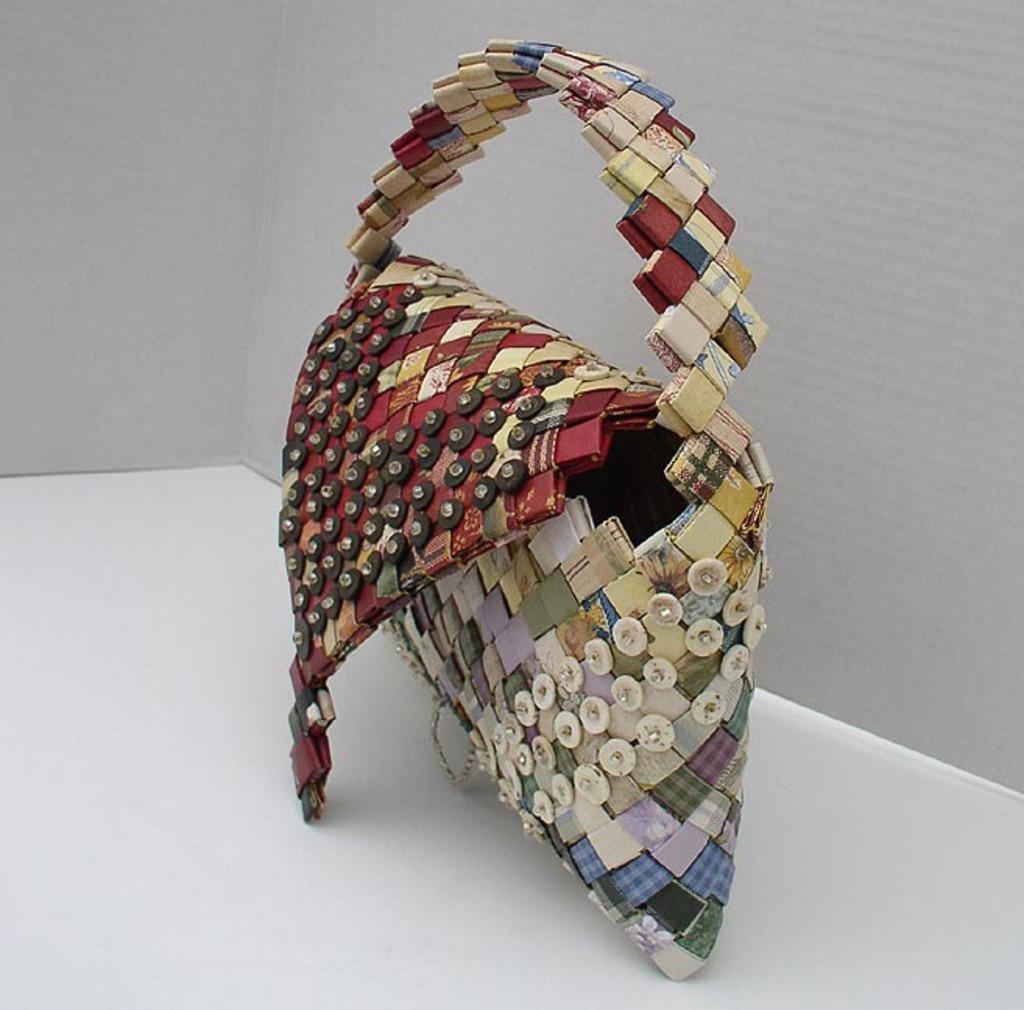Please provide a concise description of this image. In this image I can see a handbag. 